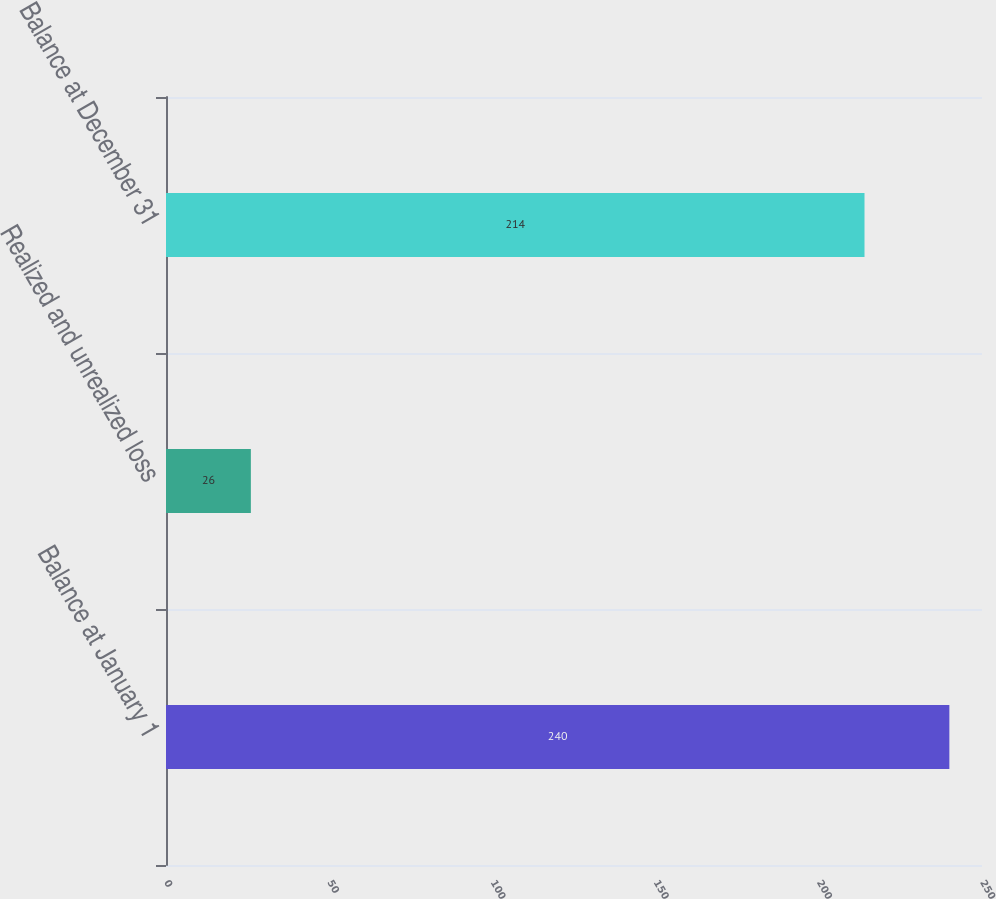Convert chart to OTSL. <chart><loc_0><loc_0><loc_500><loc_500><bar_chart><fcel>Balance at January 1<fcel>Realized and unrealized loss<fcel>Balance at December 31<nl><fcel>240<fcel>26<fcel>214<nl></chart> 